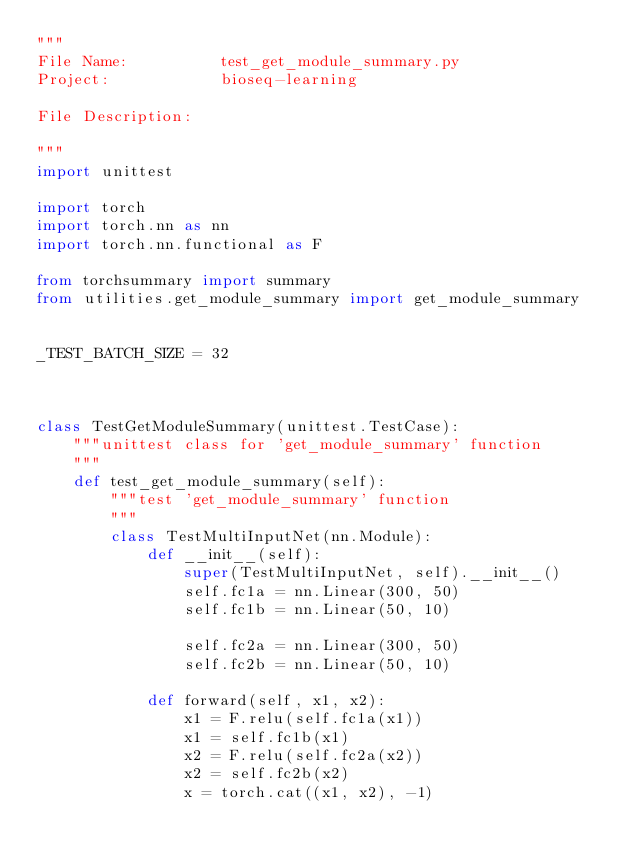Convert code to text. <code><loc_0><loc_0><loc_500><loc_500><_Python_>"""
File Name:          test_get_module_summary.py
Project:            bioseq-learning

File Description:

"""
import unittest

import torch
import torch.nn as nn
import torch.nn.functional as F

from torchsummary import summary
from utilities.get_module_summary import get_module_summary


_TEST_BATCH_SIZE = 32



class TestGetModuleSummary(unittest.TestCase):
    """unittest class for 'get_module_summary' function
    """
    def test_get_module_summary(self):
        """test 'get_module_summary' function
        """
        class TestMultiInputNet(nn.Module):
            def __init__(self):
                super(TestMultiInputNet, self).__init__()
                self.fc1a = nn.Linear(300, 50)
                self.fc1b = nn.Linear(50, 10)

                self.fc2a = nn.Linear(300, 50)
                self.fc2b = nn.Linear(50, 10)

            def forward(self, x1, x2):
                x1 = F.relu(self.fc1a(x1))
                x1 = self.fc1b(x1)
                x2 = F.relu(self.fc2a(x2))
                x2 = self.fc2b(x2)
                x = torch.cat((x1, x2), -1)</code> 